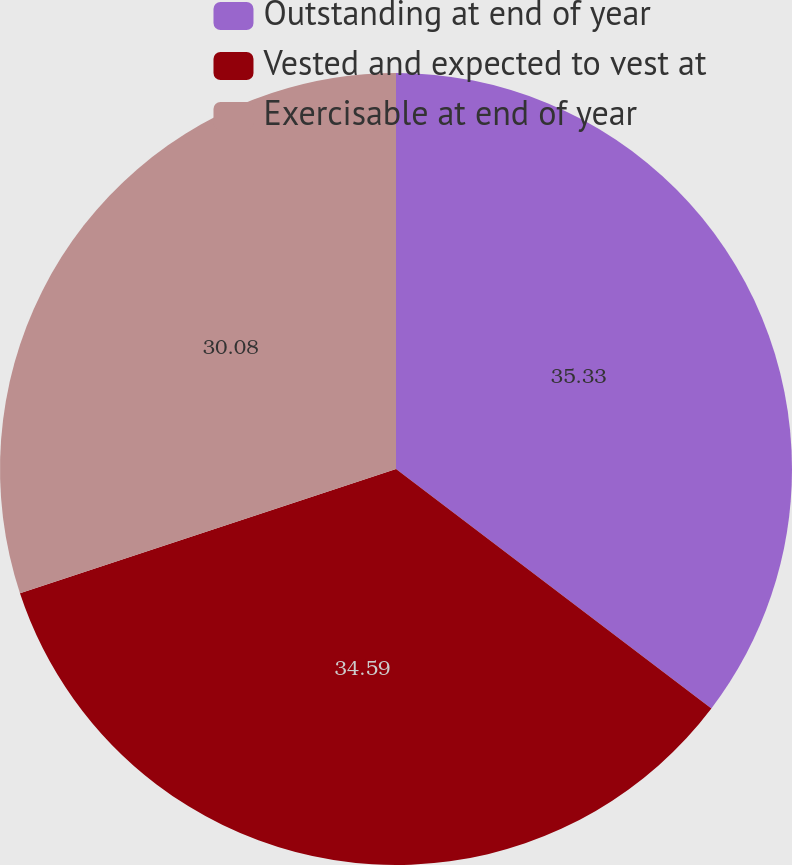Convert chart to OTSL. <chart><loc_0><loc_0><loc_500><loc_500><pie_chart><fcel>Outstanding at end of year<fcel>Vested and expected to vest at<fcel>Exercisable at end of year<nl><fcel>35.34%<fcel>34.59%<fcel>30.08%<nl></chart> 